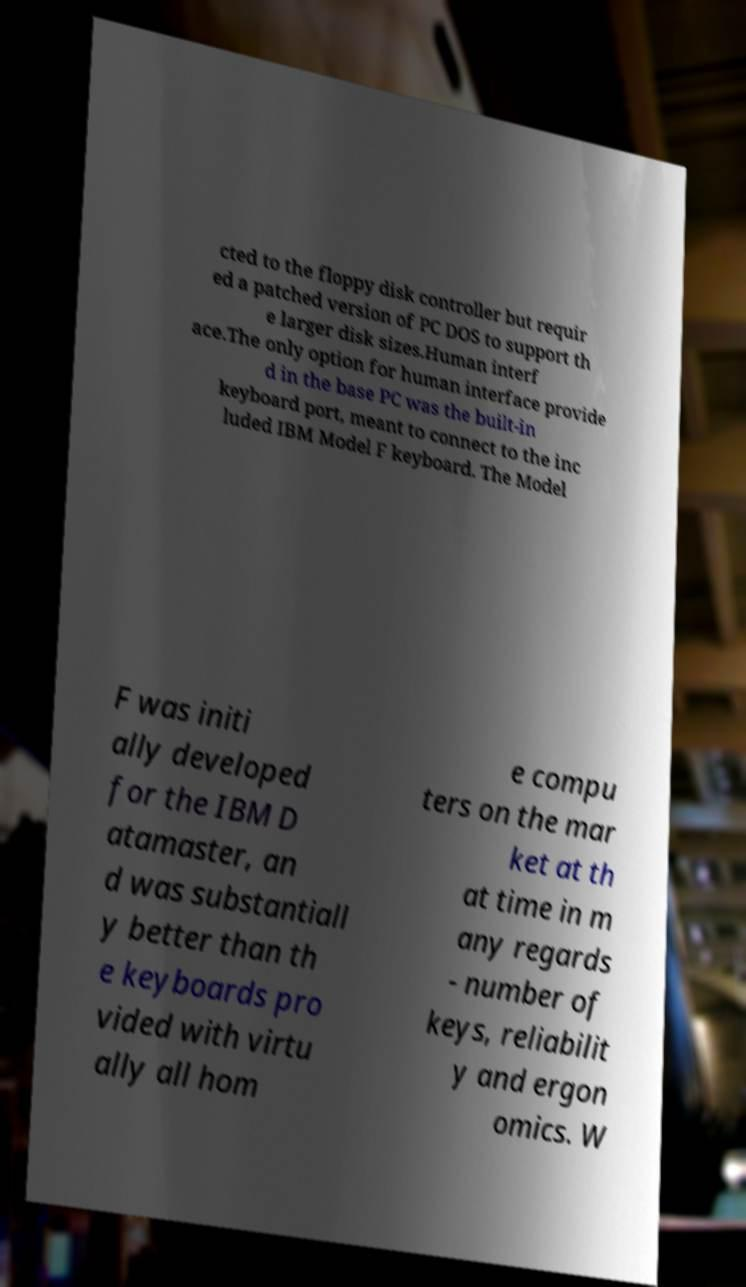Please read and relay the text visible in this image. What does it say? cted to the floppy disk controller but requir ed a patched version of PC DOS to support th e larger disk sizes.Human interf ace.The only option for human interface provide d in the base PC was the built-in keyboard port, meant to connect to the inc luded IBM Model F keyboard. The Model F was initi ally developed for the IBM D atamaster, an d was substantiall y better than th e keyboards pro vided with virtu ally all hom e compu ters on the mar ket at th at time in m any regards - number of keys, reliabilit y and ergon omics. W 